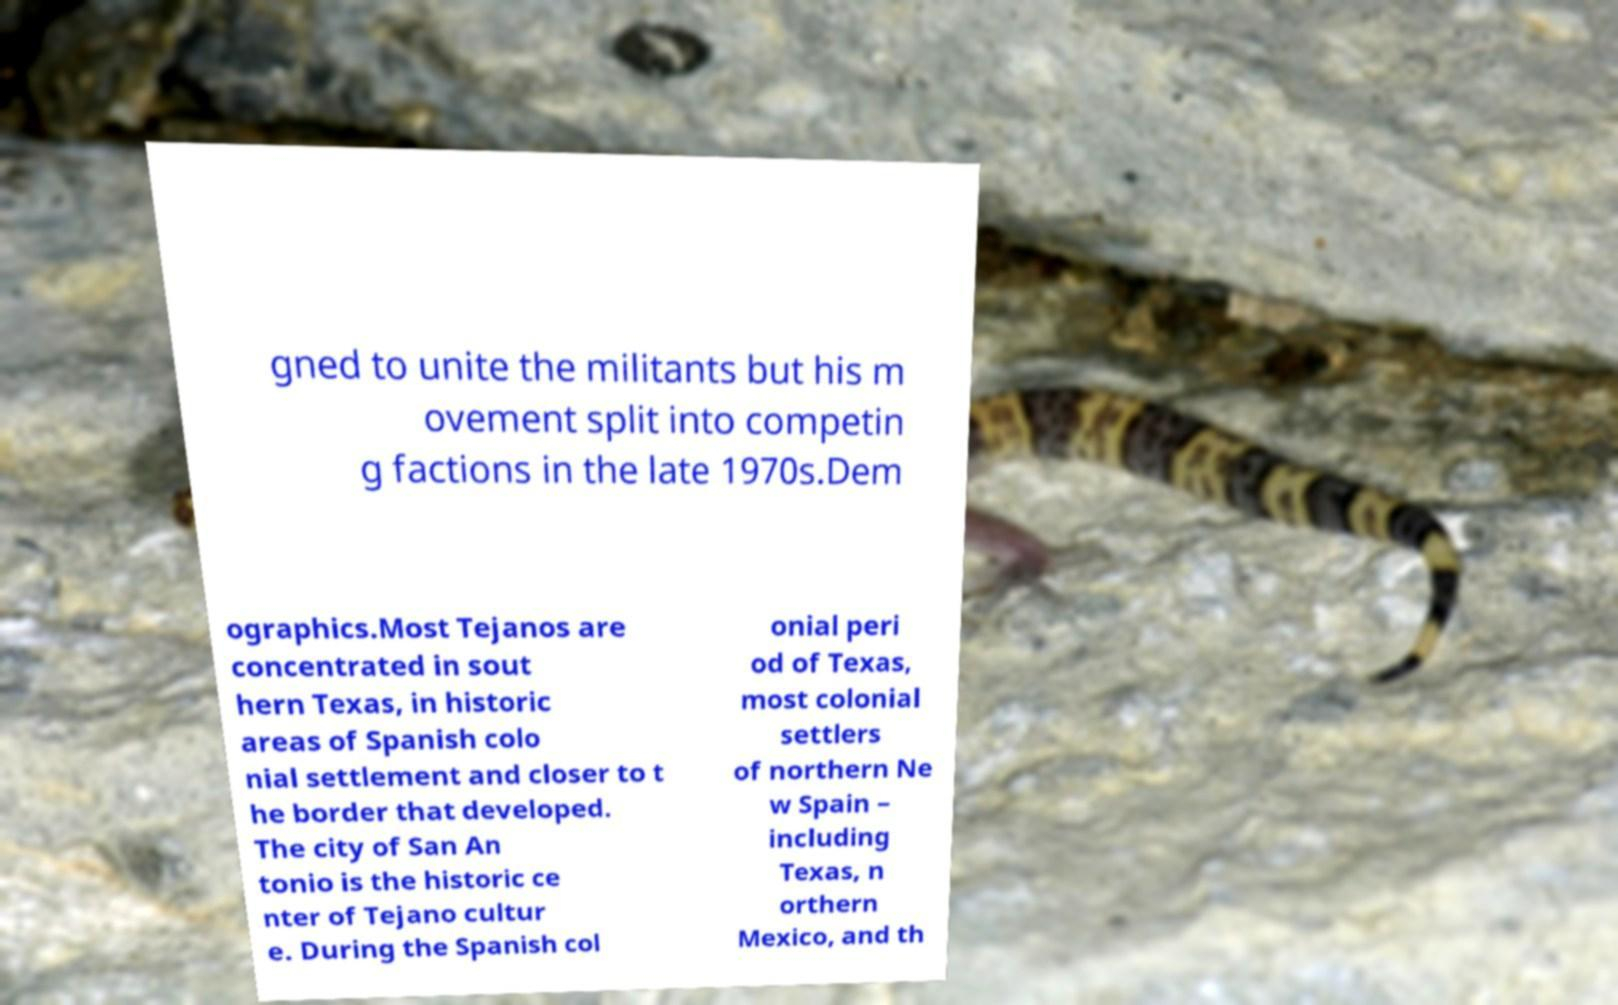Could you assist in decoding the text presented in this image and type it out clearly? gned to unite the militants but his m ovement split into competin g factions in the late 1970s.Dem ographics.Most Tejanos are concentrated in sout hern Texas, in historic areas of Spanish colo nial settlement and closer to t he border that developed. The city of San An tonio is the historic ce nter of Tejano cultur e. During the Spanish col onial peri od of Texas, most colonial settlers of northern Ne w Spain – including Texas, n orthern Mexico, and th 